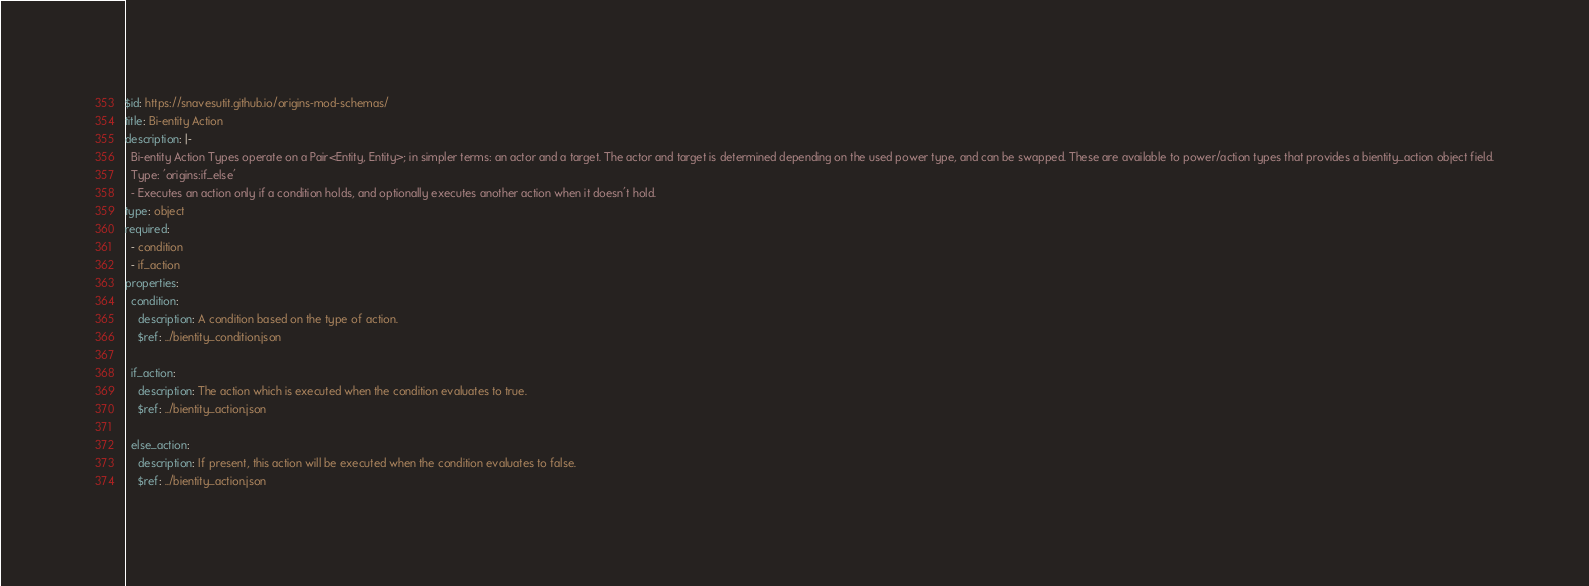<code> <loc_0><loc_0><loc_500><loc_500><_YAML_>$id: https://snavesutit.github.io/origins-mod-schemas/
title: Bi-entity Action
description: |-
  Bi-entity Action Types operate on a Pair<Entity, Entity>; in simpler terms: an actor and a target. The actor and target is determined depending on the used power type, and can be swapped. These are available to power/action types that provides a bientity_action object field.
  Type: 'origins:if_else'
  - Executes an action only if a condition holds, and optionally executes another action when it doesn't hold.
type: object
required:
  - condition
  - if_action
properties:
  condition:
    description: A condition based on the type of action.
    $ref: ../bientity_condition.json

  if_action:
    description: The action which is executed when the condition evaluates to true.
    $ref: ../bientity_action.json

  else_action:
    description: If present, this action will be executed when the condition evaluates to false.
    $ref: ../bientity_action.json
</code> 